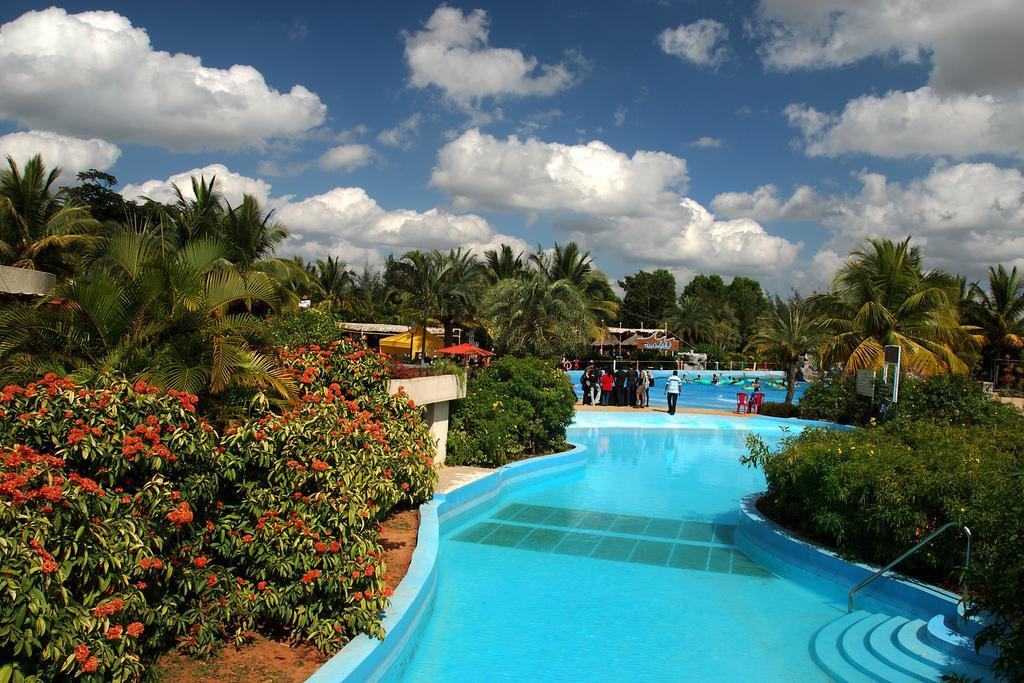How would you summarize this image in a sentence or two? In this image we can see pools and there are people. We can see plants and there are flowers. In the background there are trees, buildings and sky. 